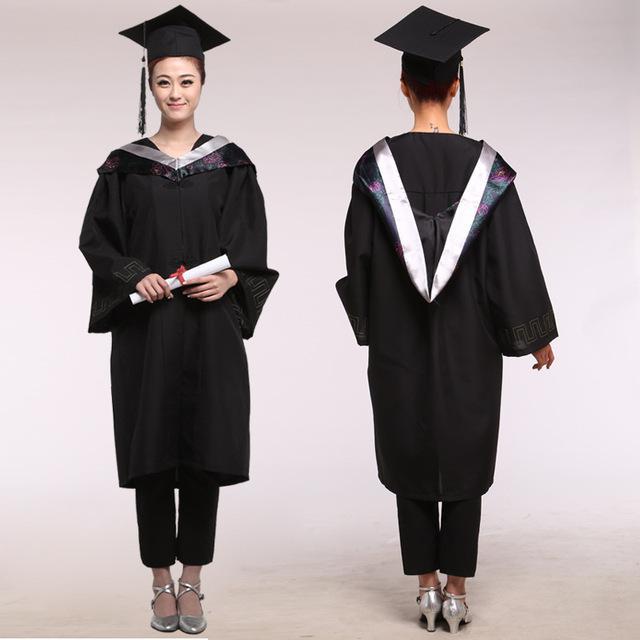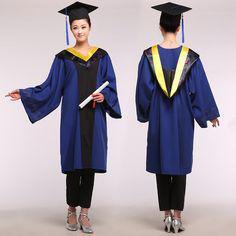The first image is the image on the left, the second image is the image on the right. Evaluate the accuracy of this statement regarding the images: "There are at most 4 graduation gowns in the image pair". Is it true? Answer yes or no. Yes. The first image is the image on the left, the second image is the image on the right. For the images shown, is this caption "In the left image, you will find no people." true? Answer yes or no. No. 